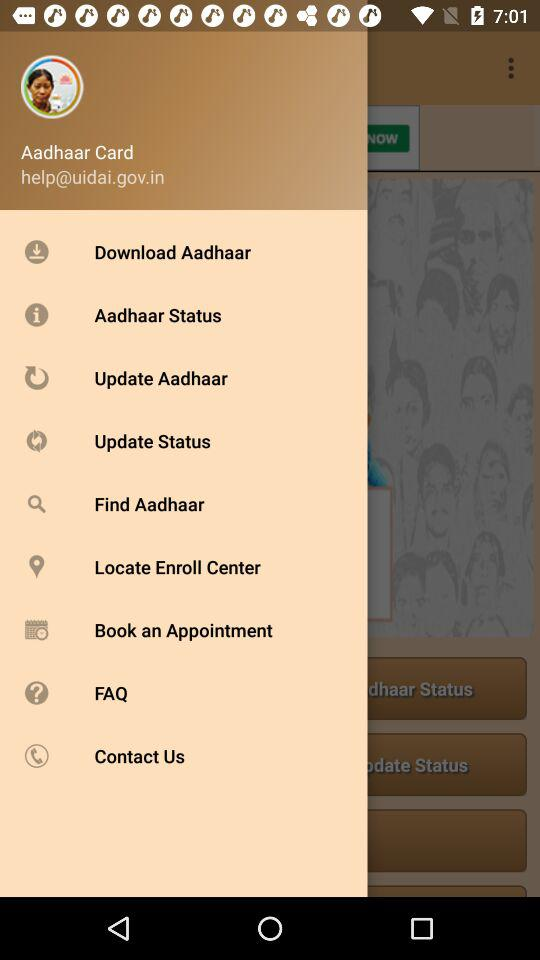What is the identity document name? The identity document name is Aadhaar Card. 